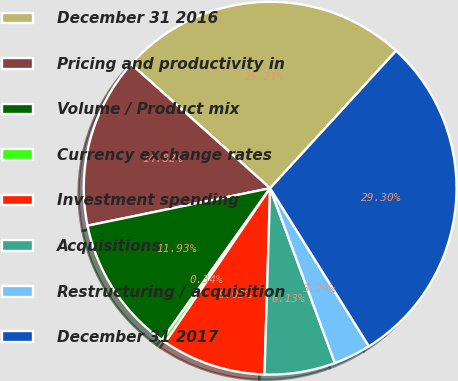Convert chart to OTSL. <chart><loc_0><loc_0><loc_500><loc_500><pie_chart><fcel>December 31 2016<fcel>Pricing and productivity in<fcel>Volume / Product mix<fcel>Currency exchange rates<fcel>Investment spending<fcel>Acquisitions<fcel>Restructuring / acquisition<fcel>December 31 2017<nl><fcel>25.21%<fcel>14.82%<fcel>11.93%<fcel>0.34%<fcel>9.03%<fcel>6.13%<fcel>3.24%<fcel>29.3%<nl></chart> 